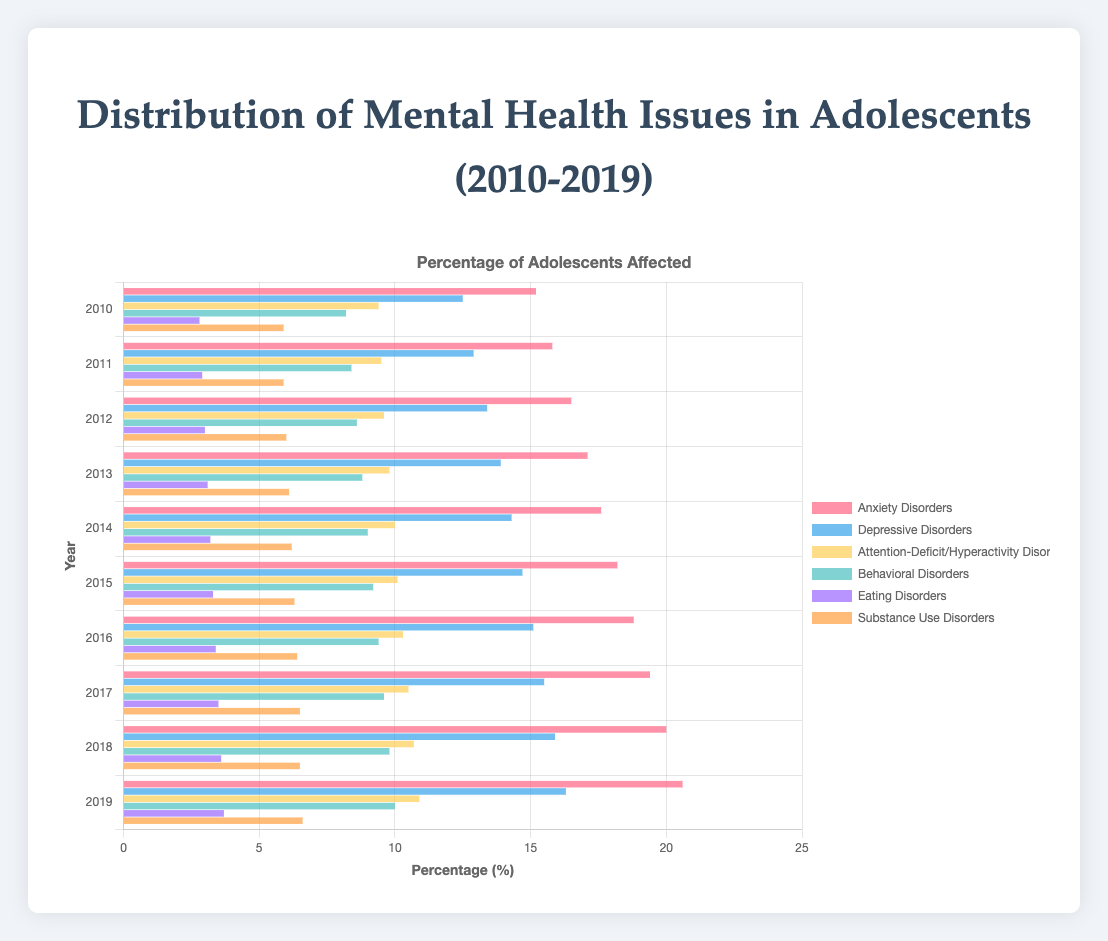What is the trend for Anxiety Disorders from 2010 to 2019? The Anxiety Disorders percentages increase each year from 15.2% in 2010 to 20.6% in 2019. This shows a rising trend over the years.
Answer: Increasing trend Which type of mental health issue had the highest percentage in 2019? In 2019, Anxiety Disorders had the highest percentage at 20.6%, as indicated by the highest horizontal bar in the chart.
Answer: Anxiety Disorders By how much did the percentage of Depressive Disorders increase from 2010 to 2019? The percentage of Depressive Disorders was 12.5% in 2010 and increased to 16.3% in 2019. The difference is 16.3% - 12.5% = 3.8%.
Answer: 3.8% How many types of mental health issues were tracked in this chart? The chart includes Anxiety Disorders, Depressive Disorders, Attention-Deficit/Hyperactivity Disorder, Behavioral Disorders, Eating Disorders, and Substance Use Disorders—six types in total.
Answer: 6 Which type of disorder had the smallest increase in percentage from 2010 to 2019? Substance Use Disorders increased from 5.9% in 2010 to 6.6% in 2019. The increase is 6.6% - 5.9% = 0.7%. This is the smallest increase compared to other types.
Answer: Substance Use Disorders What was the percentage of Behavioral Disorders in 2015? On the horizontal bar representing the year 2015 for Behavioral Disorders, the percentage shown is 9.2%.
Answer: 9.2% Which two mental health issues had a similar percentage in 2019? In 2019, both Depressive Disorders (16.3%) and Attention-Deficit/Hyperactivity Disorder (10.9%) had similar values to their respective trends.
Answer: None Compare the percentage increase of Eating Disorders and Attention-Deficit/Hyperactivity Disorder from 2010 to 2019. Which one had a larger increase? Eating Disorders increased from 2.8% to 3.7% (0.9%), and Attention-Deficit/Hyperactivity Disorder increased from 9.4% to 10.9% (1.5%). Attention-Deficit/Hyperactivity Disorder had a larger increase.
Answer: Attention-Deficit/Hyperactivity Disorder Compute the average percentage of Anxiety Disorders over the 10-year period. To find the average, add all the percentages for Anxiety Disorders from 2010 to 2019 and divide by the number of years: (15.2 + 15.8 + 16.5 + 17.1 + 17.6 + 18.2 + 18.8 + 19.4 + 20.0 + 20.6) / 10 = 17.42%.
Answer: 17.42% 